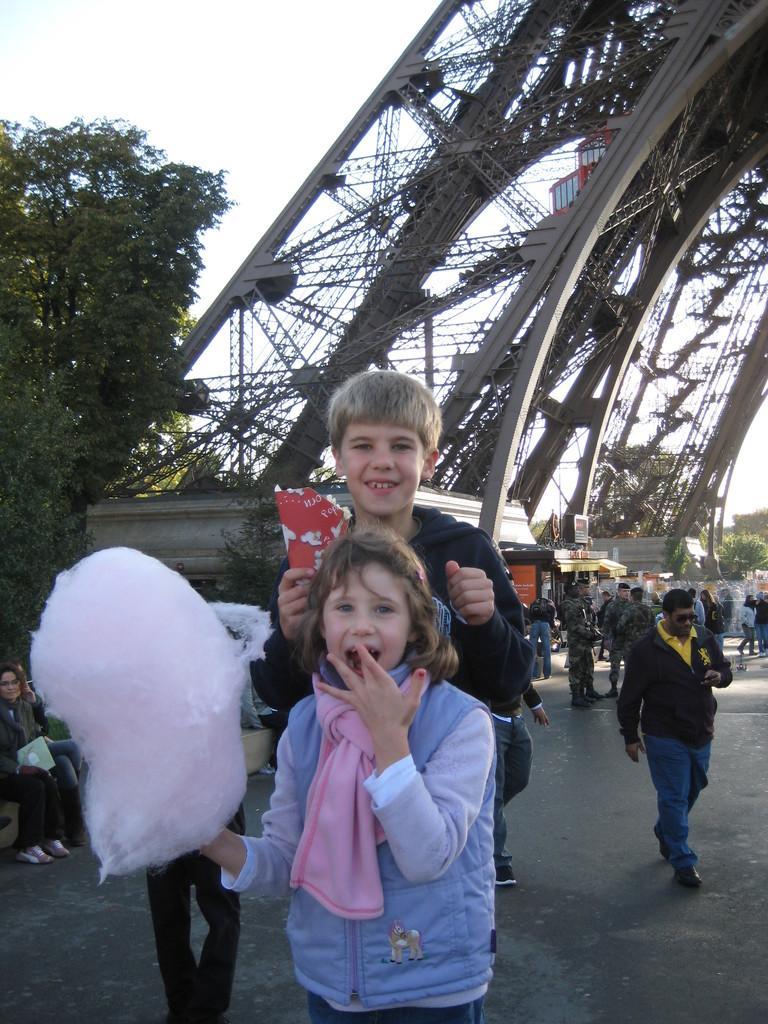Could you give a brief overview of what you see in this image? The girl in the blue jacket is standing in front of the picture. Behind her, the boy in black jacket is standing. Both of them are smiling. Behind them, we see people standing on the road. The man in yellow T-shirt and black jacket is walking on the road. At the top of the picture, we see a giant wheel. On the left side, we see people sitting on the bench. There are many trees in the background. This picture is clicked outside the city. 